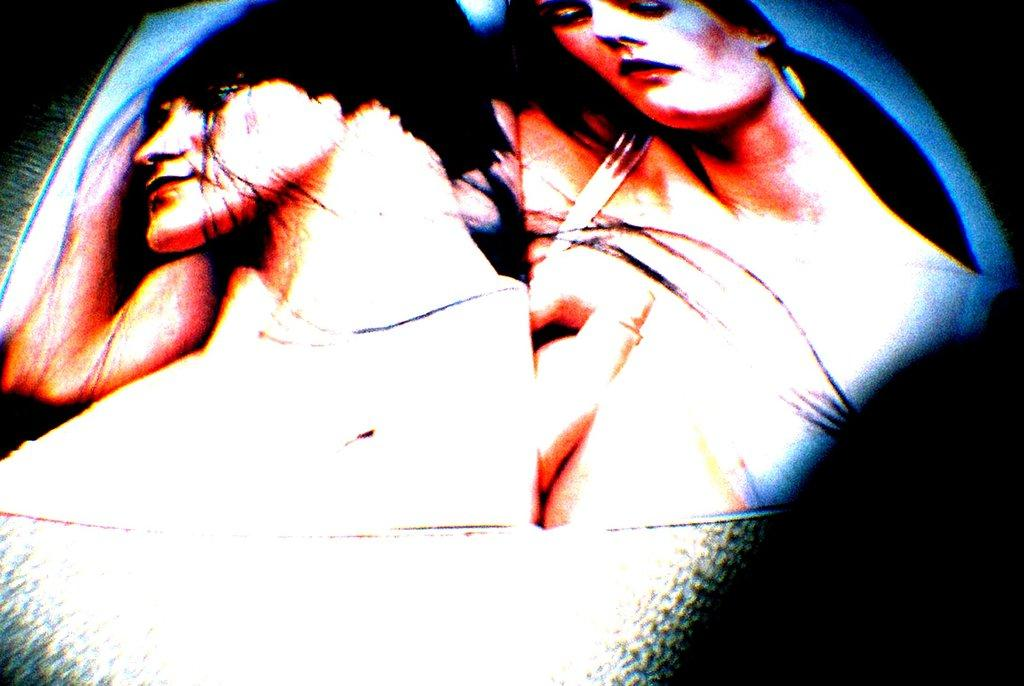What subjects are depicted in the image? There is a picture of a man and a picture of a woman in the image. Can you describe the gender of the subjects in the image? The subjects in the image are a man and a woman. What type of soda is being poured into the glass in the image? There is no glass or soda present in the image; it only contains pictures of a man and a woman. In which direction is the woman facing in the image? The direction the woman is facing cannot be determined from the image, as it only shows a picture of her. 